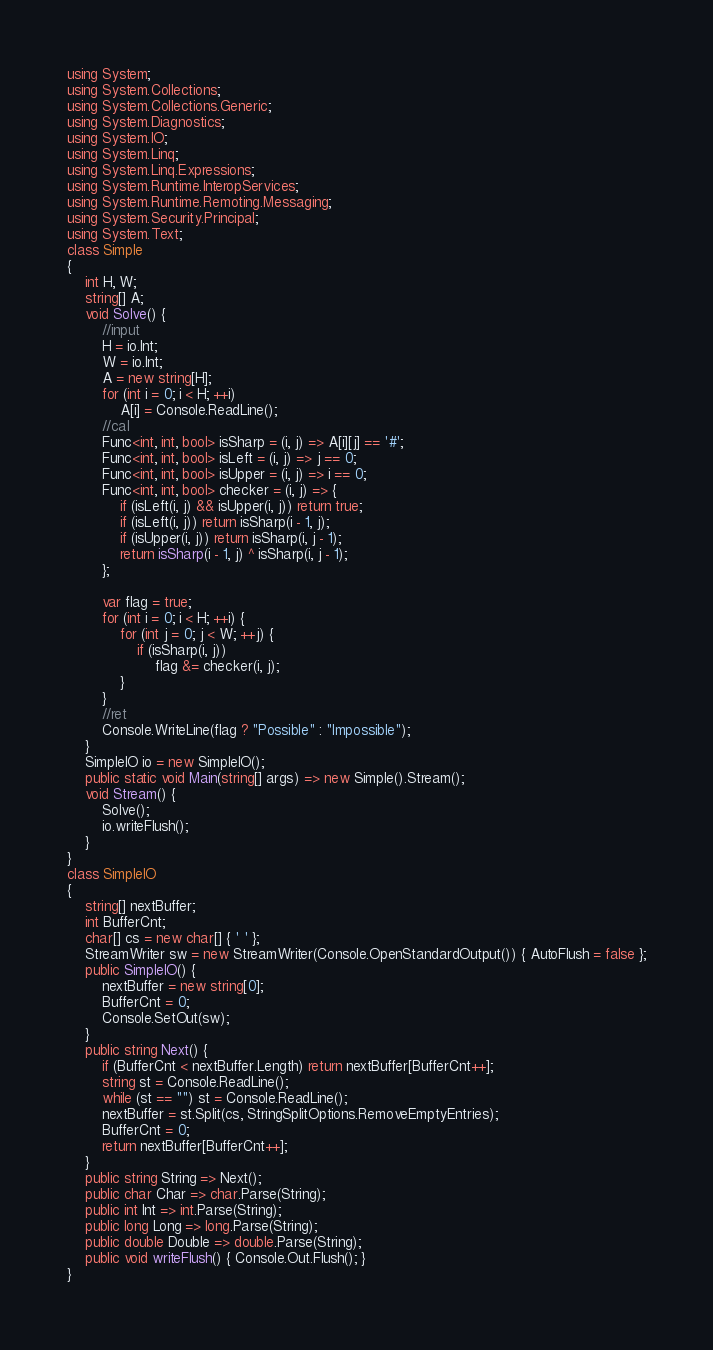Convert code to text. <code><loc_0><loc_0><loc_500><loc_500><_C#_>using System;
using System.Collections;
using System.Collections.Generic;
using System.Diagnostics;
using System.IO;
using System.Linq;
using System.Linq.Expressions;
using System.Runtime.InteropServices;
using System.Runtime.Remoting.Messaging;
using System.Security.Principal;
using System.Text;
class Simple
{
    int H, W;
    string[] A;
    void Solve() {
        //input
        H = io.Int;
        W = io.Int;
        A = new string[H];
        for (int i = 0; i < H; ++i)
            A[i] = Console.ReadLine();
        //cal
        Func<int, int, bool> isSharp = (i, j) => A[i][j] == '#';
        Func<int, int, bool> isLeft = (i, j) => j == 0;
        Func<int, int, bool> isUpper = (i, j) => i == 0;
        Func<int, int, bool> checker = (i, j) => {
            if (isLeft(i, j) && isUpper(i, j)) return true;
            if (isLeft(i, j)) return isSharp(i - 1, j);
            if (isUpper(i, j)) return isSharp(i, j - 1);
            return isSharp(i - 1, j) ^ isSharp(i, j - 1);
        };

        var flag = true;
        for (int i = 0; i < H; ++i) {
            for (int j = 0; j < W; ++j) {
                if (isSharp(i, j))
                    flag &= checker(i, j);
            }
        }
        //ret
        Console.WriteLine(flag ? "Possible" : "Impossible");
    }
    SimpleIO io = new SimpleIO();
    public static void Main(string[] args) => new Simple().Stream();
    void Stream() {
        Solve();
        io.writeFlush();
    }
}
class SimpleIO
{
    string[] nextBuffer;
    int BufferCnt;
    char[] cs = new char[] { ' ' };
    StreamWriter sw = new StreamWriter(Console.OpenStandardOutput()) { AutoFlush = false };
    public SimpleIO() {
        nextBuffer = new string[0];
        BufferCnt = 0;
        Console.SetOut(sw);
    }
    public string Next() {
        if (BufferCnt < nextBuffer.Length) return nextBuffer[BufferCnt++];
        string st = Console.ReadLine();
        while (st == "") st = Console.ReadLine();
        nextBuffer = st.Split(cs, StringSplitOptions.RemoveEmptyEntries);
        BufferCnt = 0;
        return nextBuffer[BufferCnt++];
    }
    public string String => Next();
    public char Char => char.Parse(String);
    public int Int => int.Parse(String);
    public long Long => long.Parse(String);
    public double Double => double.Parse(String);
    public void writeFlush() { Console.Out.Flush(); }
}
</code> 